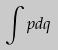Convert formula to latex. <formula><loc_0><loc_0><loc_500><loc_500>\int p d q</formula> 